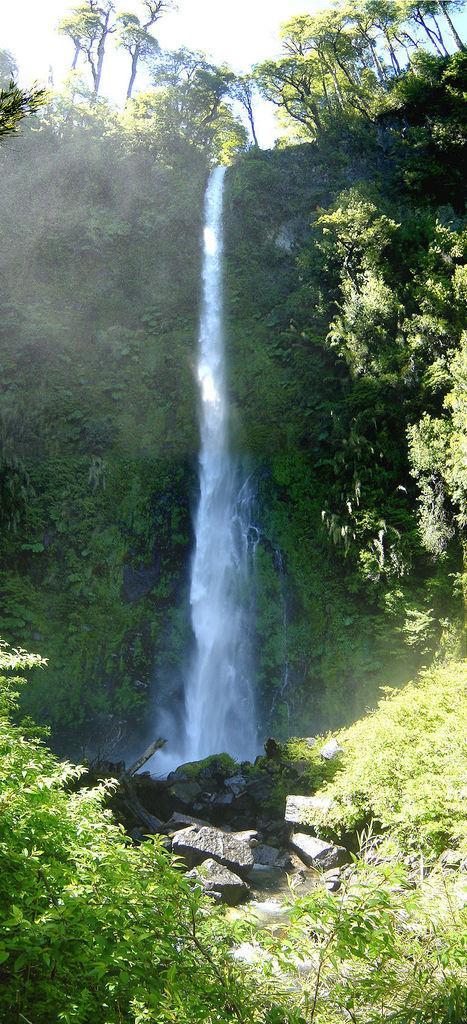Please provide a concise description of this image. In the center of the image there is a waterfall. At the bottom there are rocks and we can see trees. At the top there is sky. 